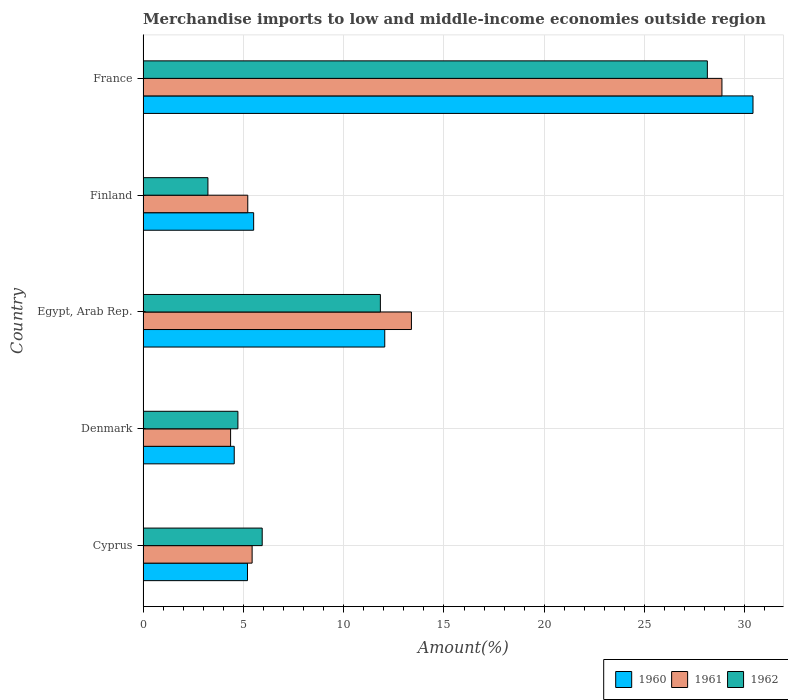How many different coloured bars are there?
Provide a succinct answer. 3. What is the label of the 4th group of bars from the top?
Offer a terse response. Denmark. In how many cases, is the number of bars for a given country not equal to the number of legend labels?
Offer a terse response. 0. What is the percentage of amount earned from merchandise imports in 1960 in France?
Give a very brief answer. 30.4. Across all countries, what is the maximum percentage of amount earned from merchandise imports in 1962?
Your answer should be compact. 28.13. Across all countries, what is the minimum percentage of amount earned from merchandise imports in 1960?
Provide a short and direct response. 4.54. In which country was the percentage of amount earned from merchandise imports in 1961 maximum?
Ensure brevity in your answer.  France. In which country was the percentage of amount earned from merchandise imports in 1962 minimum?
Ensure brevity in your answer.  Finland. What is the total percentage of amount earned from merchandise imports in 1961 in the graph?
Provide a succinct answer. 57.25. What is the difference between the percentage of amount earned from merchandise imports in 1961 in Denmark and that in Finland?
Provide a succinct answer. -0.86. What is the difference between the percentage of amount earned from merchandise imports in 1960 in Denmark and the percentage of amount earned from merchandise imports in 1962 in Finland?
Provide a succinct answer. 1.31. What is the average percentage of amount earned from merchandise imports in 1960 per country?
Provide a short and direct response. 11.54. What is the difference between the percentage of amount earned from merchandise imports in 1960 and percentage of amount earned from merchandise imports in 1962 in Cyprus?
Give a very brief answer. -0.73. In how many countries, is the percentage of amount earned from merchandise imports in 1962 greater than 18 %?
Ensure brevity in your answer.  1. What is the ratio of the percentage of amount earned from merchandise imports in 1961 in Egypt, Arab Rep. to that in Finland?
Your answer should be very brief. 2.56. Is the difference between the percentage of amount earned from merchandise imports in 1960 in Denmark and Finland greater than the difference between the percentage of amount earned from merchandise imports in 1962 in Denmark and Finland?
Provide a short and direct response. No. What is the difference between the highest and the second highest percentage of amount earned from merchandise imports in 1961?
Keep it short and to the point. 15.48. What is the difference between the highest and the lowest percentage of amount earned from merchandise imports in 1960?
Ensure brevity in your answer.  25.86. Is the sum of the percentage of amount earned from merchandise imports in 1960 in Cyprus and Egypt, Arab Rep. greater than the maximum percentage of amount earned from merchandise imports in 1962 across all countries?
Keep it short and to the point. No. What does the 1st bar from the top in Cyprus represents?
Offer a very short reply. 1962. How many countries are there in the graph?
Your answer should be compact. 5. Are the values on the major ticks of X-axis written in scientific E-notation?
Give a very brief answer. No. Does the graph contain any zero values?
Your answer should be compact. No. Does the graph contain grids?
Your answer should be very brief. Yes. What is the title of the graph?
Keep it short and to the point. Merchandise imports to low and middle-income economies outside region. What is the label or title of the X-axis?
Ensure brevity in your answer.  Amount(%). What is the label or title of the Y-axis?
Keep it short and to the point. Country. What is the Amount(%) in 1960 in Cyprus?
Your answer should be compact. 5.21. What is the Amount(%) in 1961 in Cyprus?
Keep it short and to the point. 5.44. What is the Amount(%) of 1962 in Cyprus?
Provide a short and direct response. 5.94. What is the Amount(%) of 1960 in Denmark?
Make the answer very short. 4.54. What is the Amount(%) of 1961 in Denmark?
Offer a terse response. 4.36. What is the Amount(%) of 1962 in Denmark?
Provide a short and direct response. 4.73. What is the Amount(%) in 1960 in Egypt, Arab Rep.?
Your answer should be compact. 12.05. What is the Amount(%) of 1961 in Egypt, Arab Rep.?
Provide a succinct answer. 13.38. What is the Amount(%) of 1962 in Egypt, Arab Rep.?
Your answer should be compact. 11.83. What is the Amount(%) of 1960 in Finland?
Provide a short and direct response. 5.51. What is the Amount(%) in 1961 in Finland?
Give a very brief answer. 5.22. What is the Amount(%) in 1962 in Finland?
Make the answer very short. 3.23. What is the Amount(%) of 1960 in France?
Offer a very short reply. 30.4. What is the Amount(%) in 1961 in France?
Provide a succinct answer. 28.86. What is the Amount(%) of 1962 in France?
Provide a short and direct response. 28.13. Across all countries, what is the maximum Amount(%) in 1960?
Offer a terse response. 30.4. Across all countries, what is the maximum Amount(%) of 1961?
Your answer should be compact. 28.86. Across all countries, what is the maximum Amount(%) of 1962?
Your answer should be compact. 28.13. Across all countries, what is the minimum Amount(%) of 1960?
Give a very brief answer. 4.54. Across all countries, what is the minimum Amount(%) of 1961?
Your answer should be compact. 4.36. Across all countries, what is the minimum Amount(%) in 1962?
Ensure brevity in your answer.  3.23. What is the total Amount(%) in 1960 in the graph?
Offer a very short reply. 57.72. What is the total Amount(%) in 1961 in the graph?
Your answer should be compact. 57.25. What is the total Amount(%) in 1962 in the graph?
Make the answer very short. 53.86. What is the difference between the Amount(%) of 1960 in Cyprus and that in Denmark?
Keep it short and to the point. 0.66. What is the difference between the Amount(%) of 1961 in Cyprus and that in Denmark?
Your response must be concise. 1.07. What is the difference between the Amount(%) of 1962 in Cyprus and that in Denmark?
Ensure brevity in your answer.  1.21. What is the difference between the Amount(%) of 1960 in Cyprus and that in Egypt, Arab Rep.?
Offer a terse response. -6.84. What is the difference between the Amount(%) of 1961 in Cyprus and that in Egypt, Arab Rep.?
Make the answer very short. -7.94. What is the difference between the Amount(%) of 1962 in Cyprus and that in Egypt, Arab Rep.?
Provide a succinct answer. -5.89. What is the difference between the Amount(%) of 1960 in Cyprus and that in Finland?
Make the answer very short. -0.31. What is the difference between the Amount(%) of 1961 in Cyprus and that in Finland?
Provide a short and direct response. 0.22. What is the difference between the Amount(%) of 1962 in Cyprus and that in Finland?
Provide a short and direct response. 2.71. What is the difference between the Amount(%) in 1960 in Cyprus and that in France?
Make the answer very short. -25.2. What is the difference between the Amount(%) of 1961 in Cyprus and that in France?
Your answer should be very brief. -23.42. What is the difference between the Amount(%) of 1962 in Cyprus and that in France?
Provide a succinct answer. -22.19. What is the difference between the Amount(%) of 1960 in Denmark and that in Egypt, Arab Rep.?
Provide a short and direct response. -7.5. What is the difference between the Amount(%) in 1961 in Denmark and that in Egypt, Arab Rep.?
Provide a short and direct response. -9.01. What is the difference between the Amount(%) in 1962 in Denmark and that in Egypt, Arab Rep.?
Provide a short and direct response. -7.1. What is the difference between the Amount(%) in 1960 in Denmark and that in Finland?
Provide a short and direct response. -0.97. What is the difference between the Amount(%) of 1961 in Denmark and that in Finland?
Make the answer very short. -0.86. What is the difference between the Amount(%) in 1962 in Denmark and that in Finland?
Offer a terse response. 1.49. What is the difference between the Amount(%) of 1960 in Denmark and that in France?
Provide a succinct answer. -25.86. What is the difference between the Amount(%) of 1961 in Denmark and that in France?
Provide a short and direct response. -24.49. What is the difference between the Amount(%) of 1962 in Denmark and that in France?
Provide a short and direct response. -23.4. What is the difference between the Amount(%) in 1960 in Egypt, Arab Rep. and that in Finland?
Give a very brief answer. 6.54. What is the difference between the Amount(%) of 1961 in Egypt, Arab Rep. and that in Finland?
Your answer should be very brief. 8.16. What is the difference between the Amount(%) of 1962 in Egypt, Arab Rep. and that in Finland?
Keep it short and to the point. 8.6. What is the difference between the Amount(%) of 1960 in Egypt, Arab Rep. and that in France?
Offer a terse response. -18.36. What is the difference between the Amount(%) in 1961 in Egypt, Arab Rep. and that in France?
Provide a short and direct response. -15.48. What is the difference between the Amount(%) of 1962 in Egypt, Arab Rep. and that in France?
Keep it short and to the point. -16.3. What is the difference between the Amount(%) in 1960 in Finland and that in France?
Your answer should be very brief. -24.89. What is the difference between the Amount(%) of 1961 in Finland and that in France?
Provide a short and direct response. -23.64. What is the difference between the Amount(%) of 1962 in Finland and that in France?
Give a very brief answer. -24.9. What is the difference between the Amount(%) of 1960 in Cyprus and the Amount(%) of 1961 in Denmark?
Your response must be concise. 0.84. What is the difference between the Amount(%) in 1960 in Cyprus and the Amount(%) in 1962 in Denmark?
Your answer should be very brief. 0.48. What is the difference between the Amount(%) of 1961 in Cyprus and the Amount(%) of 1962 in Denmark?
Keep it short and to the point. 0.71. What is the difference between the Amount(%) of 1960 in Cyprus and the Amount(%) of 1961 in Egypt, Arab Rep.?
Make the answer very short. -8.17. What is the difference between the Amount(%) of 1960 in Cyprus and the Amount(%) of 1962 in Egypt, Arab Rep.?
Your answer should be compact. -6.62. What is the difference between the Amount(%) in 1961 in Cyprus and the Amount(%) in 1962 in Egypt, Arab Rep.?
Ensure brevity in your answer.  -6.39. What is the difference between the Amount(%) in 1960 in Cyprus and the Amount(%) in 1961 in Finland?
Make the answer very short. -0.01. What is the difference between the Amount(%) in 1960 in Cyprus and the Amount(%) in 1962 in Finland?
Your answer should be very brief. 1.97. What is the difference between the Amount(%) in 1961 in Cyprus and the Amount(%) in 1962 in Finland?
Make the answer very short. 2.2. What is the difference between the Amount(%) in 1960 in Cyprus and the Amount(%) in 1961 in France?
Give a very brief answer. -23.65. What is the difference between the Amount(%) in 1960 in Cyprus and the Amount(%) in 1962 in France?
Your answer should be very brief. -22.92. What is the difference between the Amount(%) in 1961 in Cyprus and the Amount(%) in 1962 in France?
Your response must be concise. -22.69. What is the difference between the Amount(%) in 1960 in Denmark and the Amount(%) in 1961 in Egypt, Arab Rep.?
Provide a succinct answer. -8.83. What is the difference between the Amount(%) of 1960 in Denmark and the Amount(%) of 1962 in Egypt, Arab Rep.?
Your response must be concise. -7.28. What is the difference between the Amount(%) in 1961 in Denmark and the Amount(%) in 1962 in Egypt, Arab Rep.?
Offer a very short reply. -7.47. What is the difference between the Amount(%) in 1960 in Denmark and the Amount(%) in 1961 in Finland?
Keep it short and to the point. -0.67. What is the difference between the Amount(%) of 1960 in Denmark and the Amount(%) of 1962 in Finland?
Give a very brief answer. 1.31. What is the difference between the Amount(%) in 1961 in Denmark and the Amount(%) in 1962 in Finland?
Make the answer very short. 1.13. What is the difference between the Amount(%) in 1960 in Denmark and the Amount(%) in 1961 in France?
Provide a short and direct response. -24.31. What is the difference between the Amount(%) of 1960 in Denmark and the Amount(%) of 1962 in France?
Provide a succinct answer. -23.58. What is the difference between the Amount(%) of 1961 in Denmark and the Amount(%) of 1962 in France?
Keep it short and to the point. -23.77. What is the difference between the Amount(%) in 1960 in Egypt, Arab Rep. and the Amount(%) in 1961 in Finland?
Your answer should be compact. 6.83. What is the difference between the Amount(%) of 1960 in Egypt, Arab Rep. and the Amount(%) of 1962 in Finland?
Your answer should be very brief. 8.81. What is the difference between the Amount(%) in 1961 in Egypt, Arab Rep. and the Amount(%) in 1962 in Finland?
Your answer should be compact. 10.14. What is the difference between the Amount(%) in 1960 in Egypt, Arab Rep. and the Amount(%) in 1961 in France?
Offer a very short reply. -16.81. What is the difference between the Amount(%) in 1960 in Egypt, Arab Rep. and the Amount(%) in 1962 in France?
Offer a terse response. -16.08. What is the difference between the Amount(%) in 1961 in Egypt, Arab Rep. and the Amount(%) in 1962 in France?
Provide a succinct answer. -14.75. What is the difference between the Amount(%) of 1960 in Finland and the Amount(%) of 1961 in France?
Keep it short and to the point. -23.34. What is the difference between the Amount(%) in 1960 in Finland and the Amount(%) in 1962 in France?
Give a very brief answer. -22.62. What is the difference between the Amount(%) in 1961 in Finland and the Amount(%) in 1962 in France?
Provide a succinct answer. -22.91. What is the average Amount(%) in 1960 per country?
Your answer should be very brief. 11.54. What is the average Amount(%) of 1961 per country?
Offer a very short reply. 11.45. What is the average Amount(%) in 1962 per country?
Your answer should be very brief. 10.77. What is the difference between the Amount(%) of 1960 and Amount(%) of 1961 in Cyprus?
Make the answer very short. -0.23. What is the difference between the Amount(%) in 1960 and Amount(%) in 1962 in Cyprus?
Your answer should be compact. -0.73. What is the difference between the Amount(%) of 1961 and Amount(%) of 1962 in Cyprus?
Keep it short and to the point. -0.5. What is the difference between the Amount(%) of 1960 and Amount(%) of 1961 in Denmark?
Your response must be concise. 0.18. What is the difference between the Amount(%) of 1960 and Amount(%) of 1962 in Denmark?
Ensure brevity in your answer.  -0.18. What is the difference between the Amount(%) in 1961 and Amount(%) in 1962 in Denmark?
Provide a succinct answer. -0.36. What is the difference between the Amount(%) in 1960 and Amount(%) in 1961 in Egypt, Arab Rep.?
Ensure brevity in your answer.  -1.33. What is the difference between the Amount(%) in 1960 and Amount(%) in 1962 in Egypt, Arab Rep.?
Ensure brevity in your answer.  0.22. What is the difference between the Amount(%) in 1961 and Amount(%) in 1962 in Egypt, Arab Rep.?
Keep it short and to the point. 1.55. What is the difference between the Amount(%) of 1960 and Amount(%) of 1961 in Finland?
Give a very brief answer. 0.29. What is the difference between the Amount(%) of 1960 and Amount(%) of 1962 in Finland?
Offer a terse response. 2.28. What is the difference between the Amount(%) of 1961 and Amount(%) of 1962 in Finland?
Your answer should be compact. 1.99. What is the difference between the Amount(%) of 1960 and Amount(%) of 1961 in France?
Keep it short and to the point. 1.55. What is the difference between the Amount(%) in 1960 and Amount(%) in 1962 in France?
Provide a short and direct response. 2.28. What is the difference between the Amount(%) in 1961 and Amount(%) in 1962 in France?
Provide a short and direct response. 0.73. What is the ratio of the Amount(%) of 1960 in Cyprus to that in Denmark?
Offer a very short reply. 1.15. What is the ratio of the Amount(%) of 1961 in Cyprus to that in Denmark?
Provide a short and direct response. 1.25. What is the ratio of the Amount(%) in 1962 in Cyprus to that in Denmark?
Your answer should be compact. 1.26. What is the ratio of the Amount(%) in 1960 in Cyprus to that in Egypt, Arab Rep.?
Make the answer very short. 0.43. What is the ratio of the Amount(%) in 1961 in Cyprus to that in Egypt, Arab Rep.?
Your answer should be very brief. 0.41. What is the ratio of the Amount(%) of 1962 in Cyprus to that in Egypt, Arab Rep.?
Provide a short and direct response. 0.5. What is the ratio of the Amount(%) of 1960 in Cyprus to that in Finland?
Your response must be concise. 0.94. What is the ratio of the Amount(%) in 1961 in Cyprus to that in Finland?
Your answer should be compact. 1.04. What is the ratio of the Amount(%) in 1962 in Cyprus to that in Finland?
Keep it short and to the point. 1.84. What is the ratio of the Amount(%) in 1960 in Cyprus to that in France?
Ensure brevity in your answer.  0.17. What is the ratio of the Amount(%) in 1961 in Cyprus to that in France?
Provide a succinct answer. 0.19. What is the ratio of the Amount(%) in 1962 in Cyprus to that in France?
Your response must be concise. 0.21. What is the ratio of the Amount(%) in 1960 in Denmark to that in Egypt, Arab Rep.?
Offer a very short reply. 0.38. What is the ratio of the Amount(%) in 1961 in Denmark to that in Egypt, Arab Rep.?
Ensure brevity in your answer.  0.33. What is the ratio of the Amount(%) of 1962 in Denmark to that in Egypt, Arab Rep.?
Provide a succinct answer. 0.4. What is the ratio of the Amount(%) in 1960 in Denmark to that in Finland?
Provide a short and direct response. 0.82. What is the ratio of the Amount(%) of 1961 in Denmark to that in Finland?
Your response must be concise. 0.84. What is the ratio of the Amount(%) of 1962 in Denmark to that in Finland?
Keep it short and to the point. 1.46. What is the ratio of the Amount(%) in 1960 in Denmark to that in France?
Provide a short and direct response. 0.15. What is the ratio of the Amount(%) in 1961 in Denmark to that in France?
Provide a short and direct response. 0.15. What is the ratio of the Amount(%) in 1962 in Denmark to that in France?
Provide a succinct answer. 0.17. What is the ratio of the Amount(%) of 1960 in Egypt, Arab Rep. to that in Finland?
Your answer should be very brief. 2.19. What is the ratio of the Amount(%) in 1961 in Egypt, Arab Rep. to that in Finland?
Offer a terse response. 2.56. What is the ratio of the Amount(%) in 1962 in Egypt, Arab Rep. to that in Finland?
Provide a succinct answer. 3.66. What is the ratio of the Amount(%) of 1960 in Egypt, Arab Rep. to that in France?
Ensure brevity in your answer.  0.4. What is the ratio of the Amount(%) in 1961 in Egypt, Arab Rep. to that in France?
Provide a short and direct response. 0.46. What is the ratio of the Amount(%) in 1962 in Egypt, Arab Rep. to that in France?
Offer a very short reply. 0.42. What is the ratio of the Amount(%) of 1960 in Finland to that in France?
Offer a terse response. 0.18. What is the ratio of the Amount(%) in 1961 in Finland to that in France?
Your answer should be compact. 0.18. What is the ratio of the Amount(%) of 1962 in Finland to that in France?
Provide a short and direct response. 0.11. What is the difference between the highest and the second highest Amount(%) of 1960?
Provide a short and direct response. 18.36. What is the difference between the highest and the second highest Amount(%) of 1961?
Your response must be concise. 15.48. What is the difference between the highest and the second highest Amount(%) of 1962?
Your answer should be compact. 16.3. What is the difference between the highest and the lowest Amount(%) of 1960?
Provide a short and direct response. 25.86. What is the difference between the highest and the lowest Amount(%) of 1961?
Your answer should be very brief. 24.49. What is the difference between the highest and the lowest Amount(%) in 1962?
Provide a short and direct response. 24.9. 